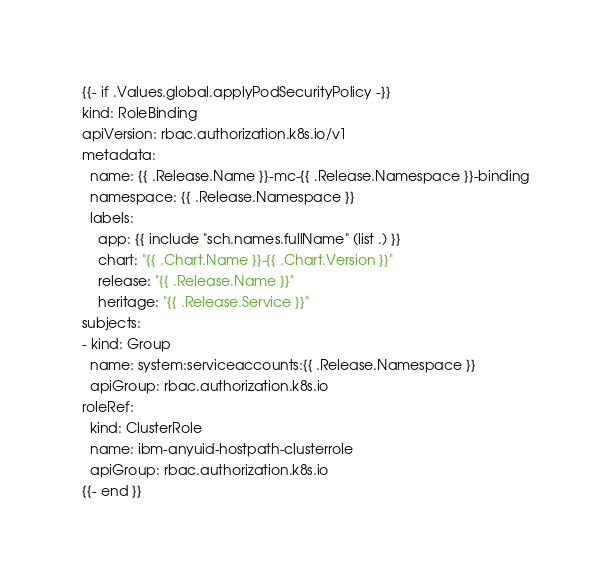Convert code to text. <code><loc_0><loc_0><loc_500><loc_500><_YAML_>{{- if .Values.global.applyPodSecurityPolicy -}}
kind: RoleBinding
apiVersion: rbac.authorization.k8s.io/v1
metadata:
  name: {{ .Release.Name }}-mc-{{ .Release.Namespace }}-binding
  namespace: {{ .Release.Namespace }}
  labels:
    app: {{ include "sch.names.fullName" (list .) }}
    chart: "{{ .Chart.Name }}-{{ .Chart.Version }}"
    release: "{{ .Release.Name }}"
    heritage: "{{ .Release.Service }}"
subjects:
- kind: Group
  name: system:serviceaccounts:{{ .Release.Namespace }}
  apiGroup: rbac.authorization.k8s.io
roleRef:
  kind: ClusterRole
  name: ibm-anyuid-hostpath-clusterrole
  apiGroup: rbac.authorization.k8s.io
{{- end }}
</code> 